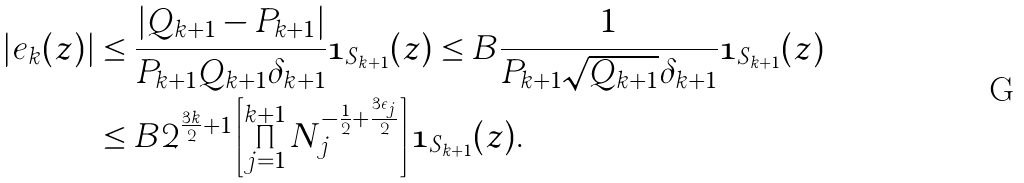Convert formula to latex. <formula><loc_0><loc_0><loc_500><loc_500>| e _ { k } ( z ) | & \leq \frac { | Q _ { k + 1 } - P _ { k + 1 } | } { P _ { k + 1 } Q _ { k + 1 } \delta _ { k + 1 } } \mathbf 1 _ { S _ { k + 1 } } ( z ) \leq B \frac { 1 } { P _ { k + 1 } \sqrt { Q _ { k + 1 } } \delta _ { k + 1 } } \mathbf 1 _ { S _ { k + 1 } } ( z ) \\ & \leq B 2 ^ { \frac { 3 k } { 2 } + 1 } \left [ \prod _ { j = 1 } ^ { k + 1 } N _ { j } ^ { - \frac { 1 } { 2 } + \frac { 3 \epsilon _ { j } } { 2 } } \right ] \mathbf 1 _ { S _ { k + 1 } } ( z ) .</formula> 